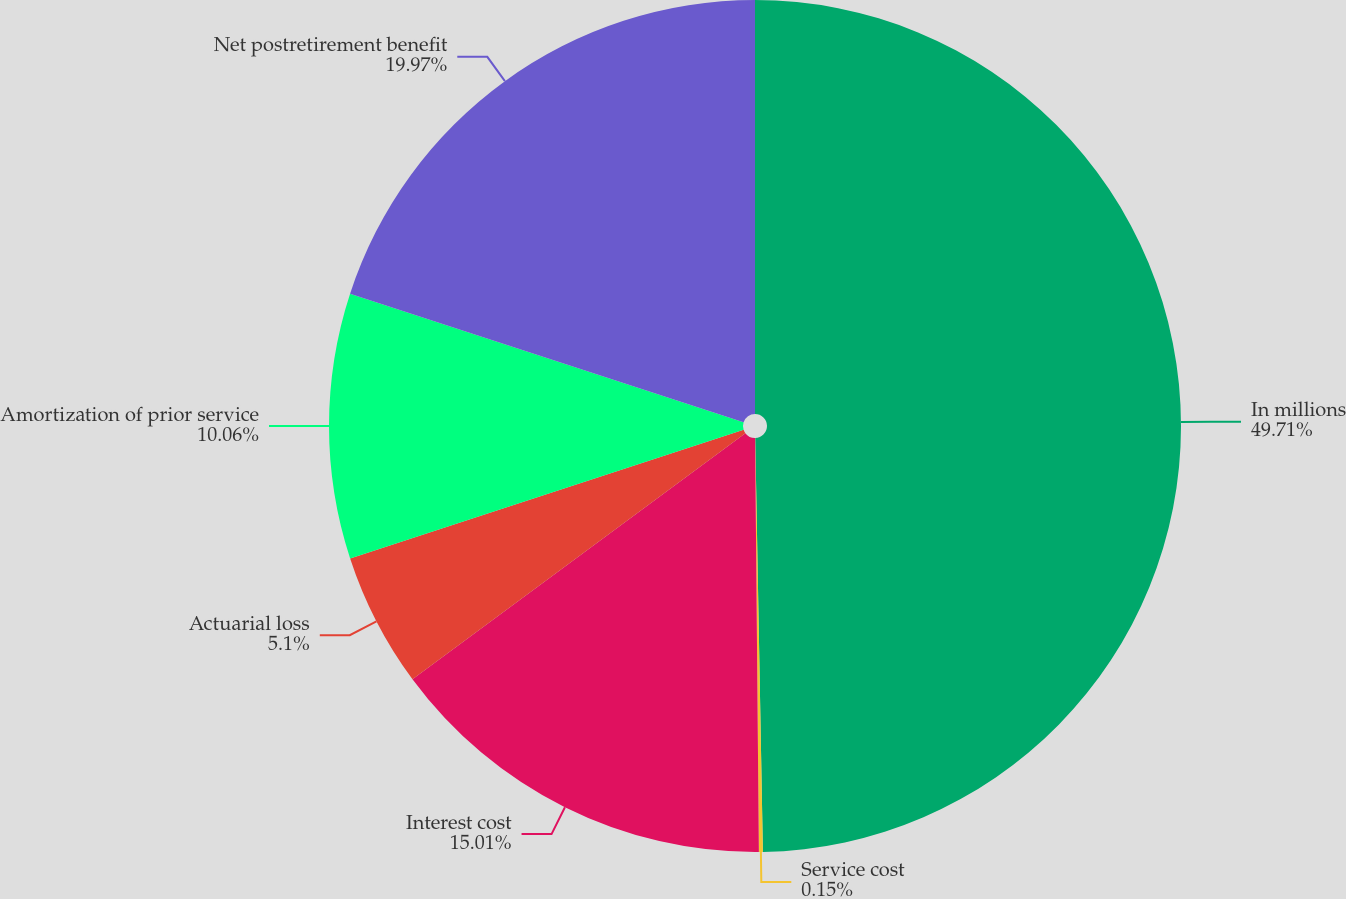<chart> <loc_0><loc_0><loc_500><loc_500><pie_chart><fcel>In millions<fcel>Service cost<fcel>Interest cost<fcel>Actuarial loss<fcel>Amortization of prior service<fcel>Net postretirement benefit<nl><fcel>49.7%<fcel>0.15%<fcel>15.01%<fcel>5.1%<fcel>10.06%<fcel>19.97%<nl></chart> 